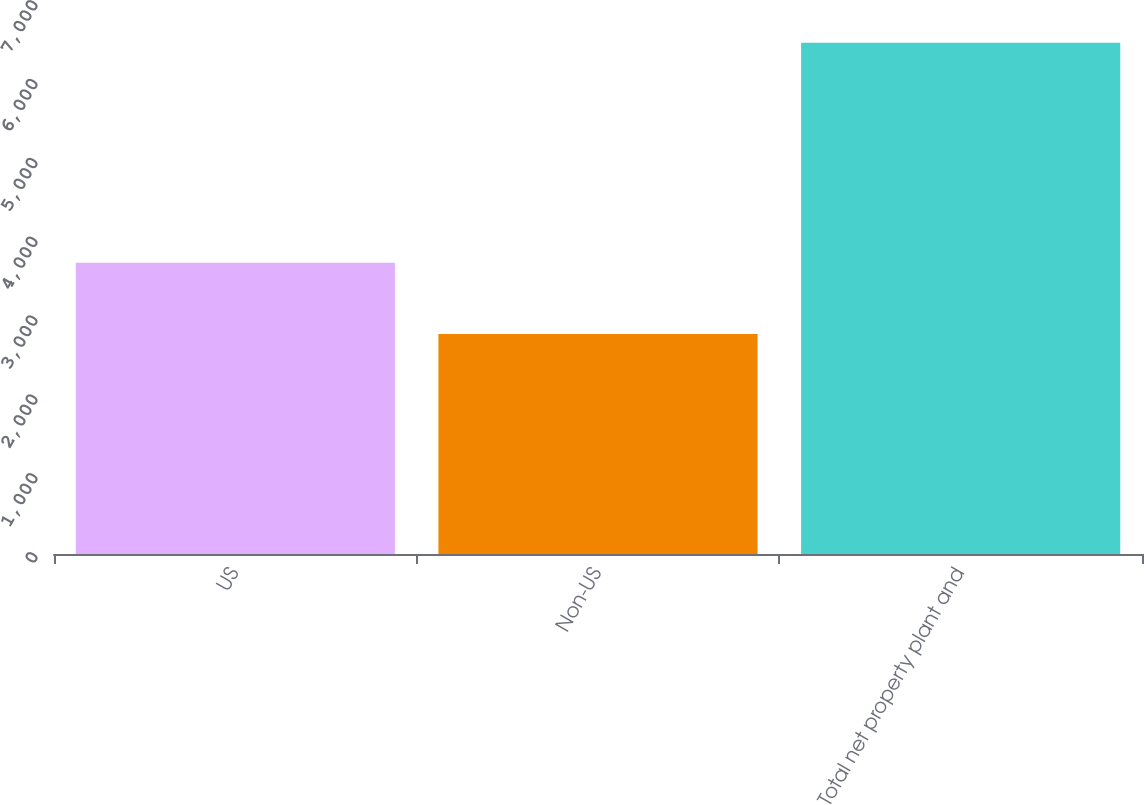<chart> <loc_0><loc_0><loc_500><loc_500><bar_chart><fcel>US<fcel>Non-US<fcel>Total net property plant and<nl><fcel>3693<fcel>2789<fcel>6482<nl></chart> 